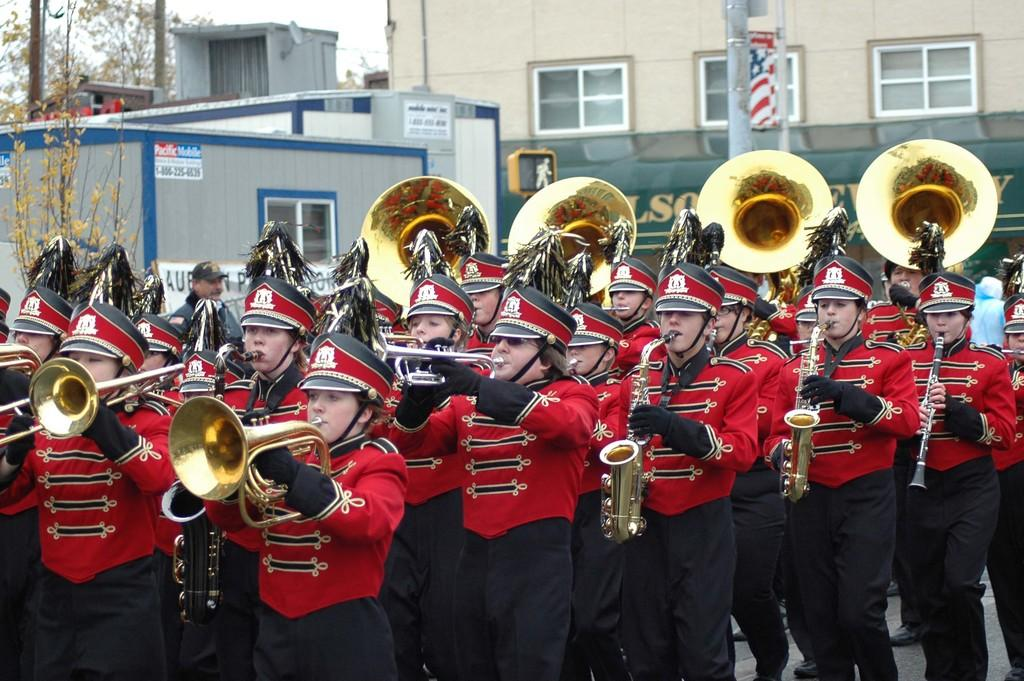How many people are in the group visible in the image? There is a group of people in the image, but the exact number is not specified. What are the people wearing on their heads? The people are wearing helmets. What are the people doing in the image? The people are playing musical instruments. What type of vegetation can be seen in the background of the image? There is a plant, trees, and sheds in the background of the image. What type of structures are visible in the background of the image? There is a building, poles, a banner, a board, and posters in the background of the image. What part of the natural environment is visible in the image? The sky is visible in the background of the image. What type of toothbrush is being used by the person playing the trumpet in the image? There is no toothbrush present in the image, and no one is shown using a toothbrush. What type of fang can be seen on the person playing the drums in the image? There are no fangs present in the image, and no one is shown with fangs. 